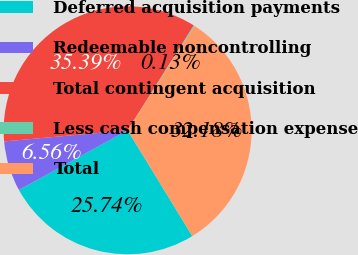<chart> <loc_0><loc_0><loc_500><loc_500><pie_chart><fcel>Deferred acquisition payments<fcel>Redeemable noncontrolling<fcel>Total contingent acquisition<fcel>Less cash compensation expense<fcel>Total<nl><fcel>25.74%<fcel>6.56%<fcel>35.39%<fcel>0.13%<fcel>32.18%<nl></chart> 